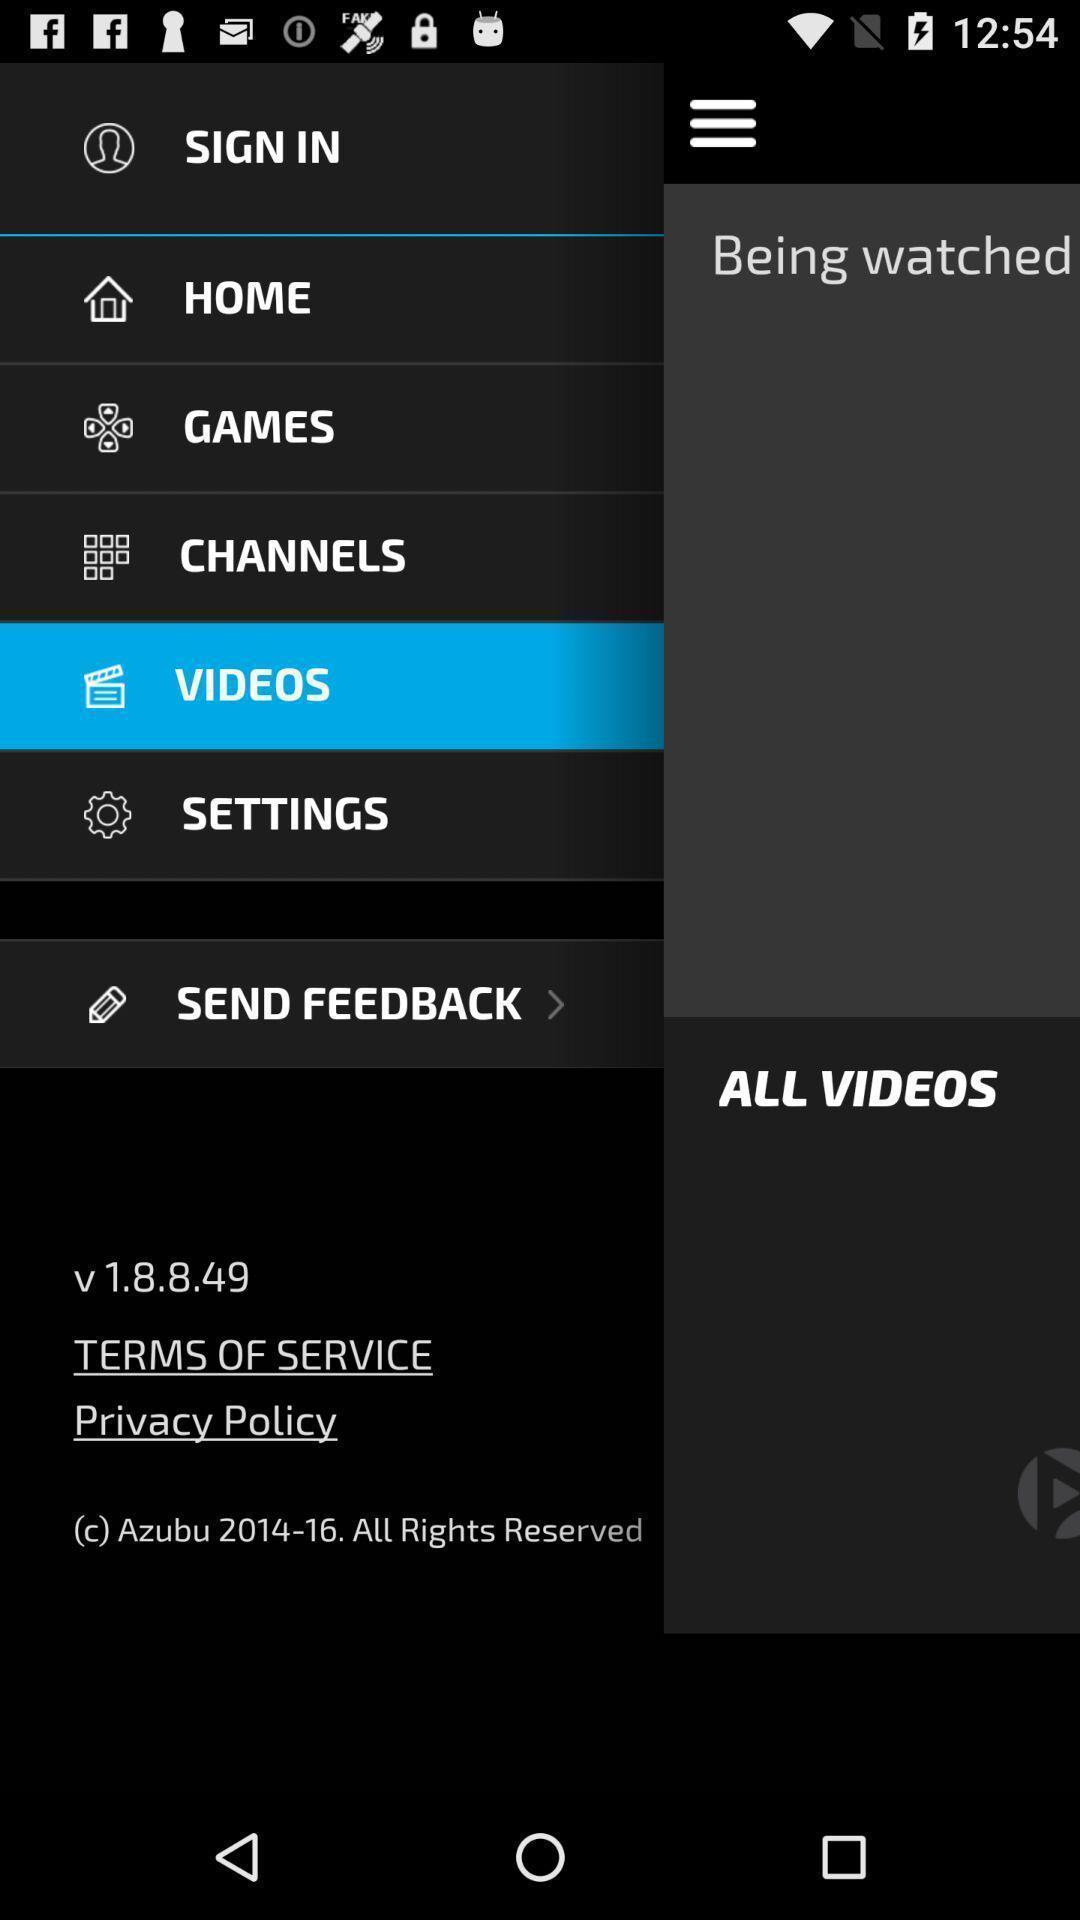Describe this image in words. Sign in page. 